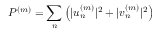Convert formula to latex. <formula><loc_0><loc_0><loc_500><loc_500>P ^ { ( m ) } = \sum _ { n } \left ( | u _ { n } ^ { ( m ) } | ^ { 2 } + | v _ { n } ^ { ( m ) } | ^ { 2 } \right )</formula> 